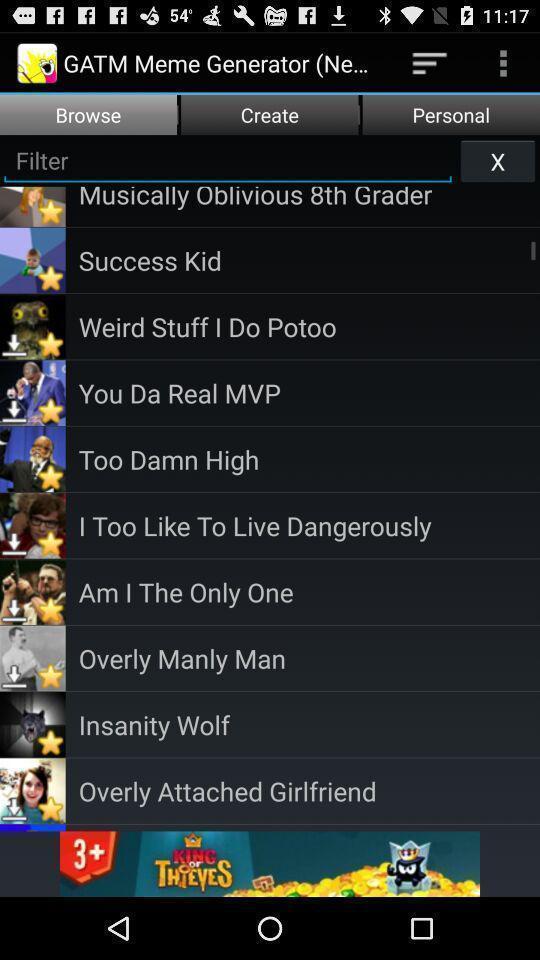Summarize the information in this screenshot. Screen shows to browse features. 